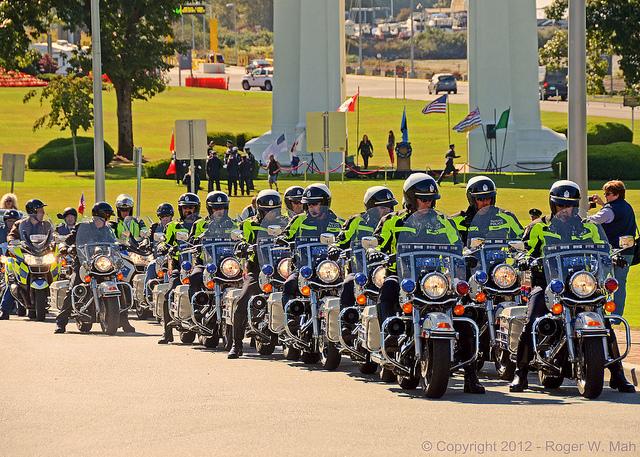What type of motorcycles are these?
Keep it brief. Police. How many flags are there?
Keep it brief. 6. Is there an event going on?
Write a very short answer. Yes. Are the motorcyclists wearing helmets?
Write a very short answer. Yes. 